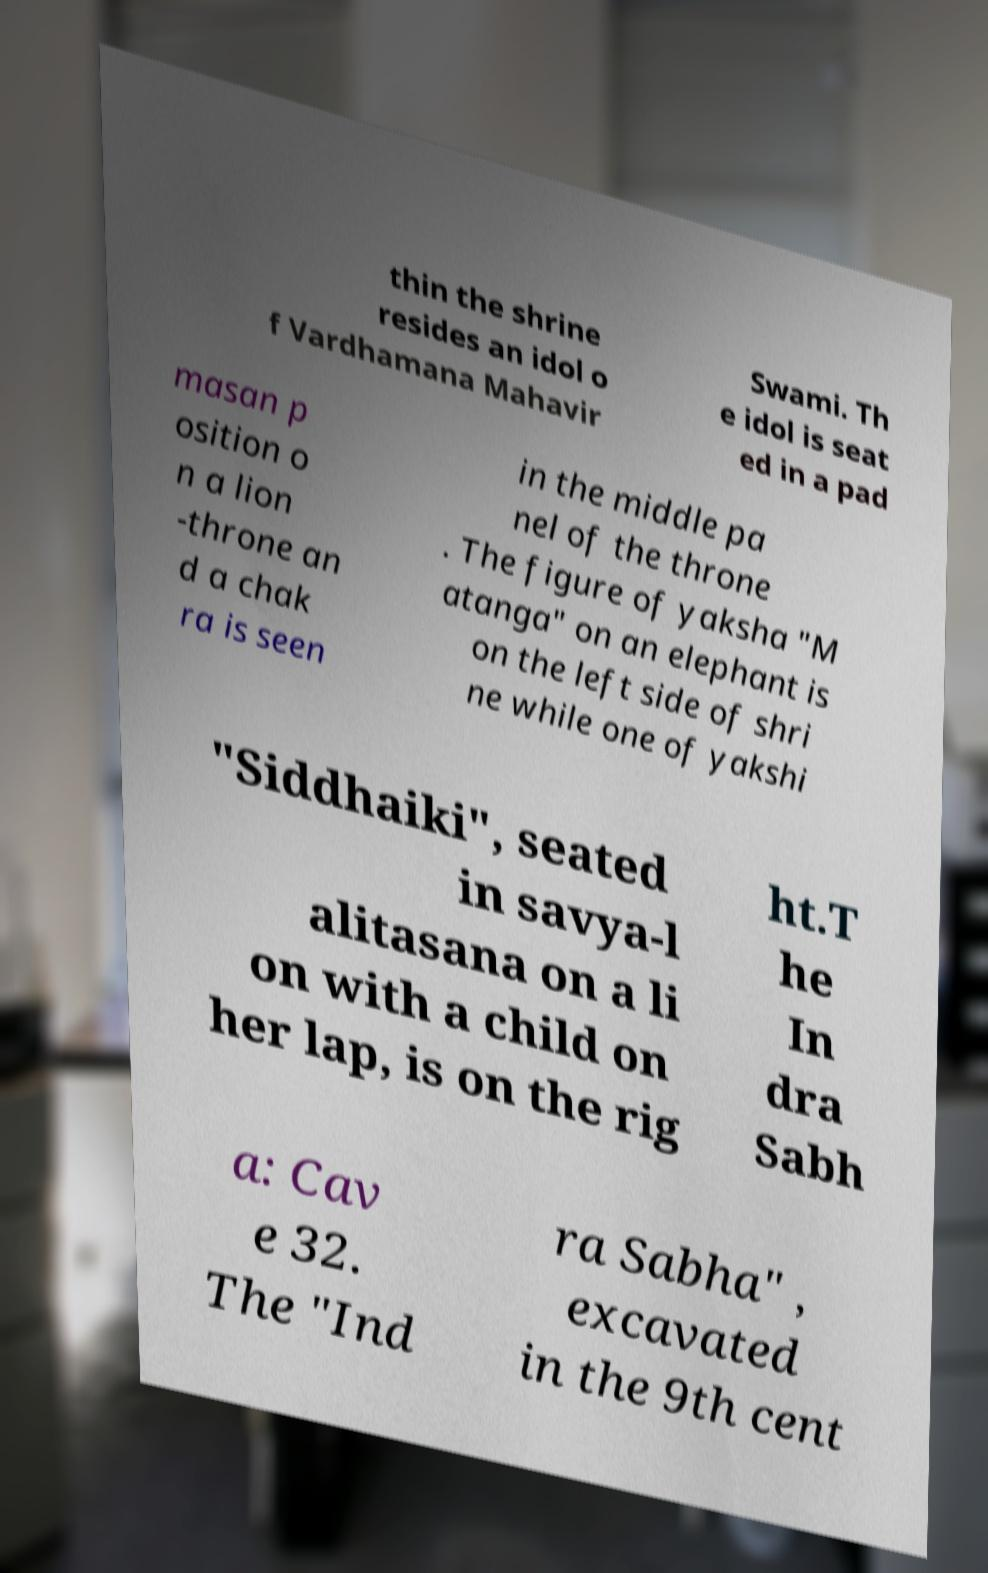Could you assist in decoding the text presented in this image and type it out clearly? thin the shrine resides an idol o f Vardhamana Mahavir Swami. Th e idol is seat ed in a pad masan p osition o n a lion -throne an d a chak ra is seen in the middle pa nel of the throne . The figure of yaksha "M atanga" on an elephant is on the left side of shri ne while one of yakshi "Siddhaiki", seated in savya-l alitasana on a li on with a child on her lap, is on the rig ht.T he In dra Sabh a: Cav e 32. The "Ind ra Sabha" , excavated in the 9th cent 